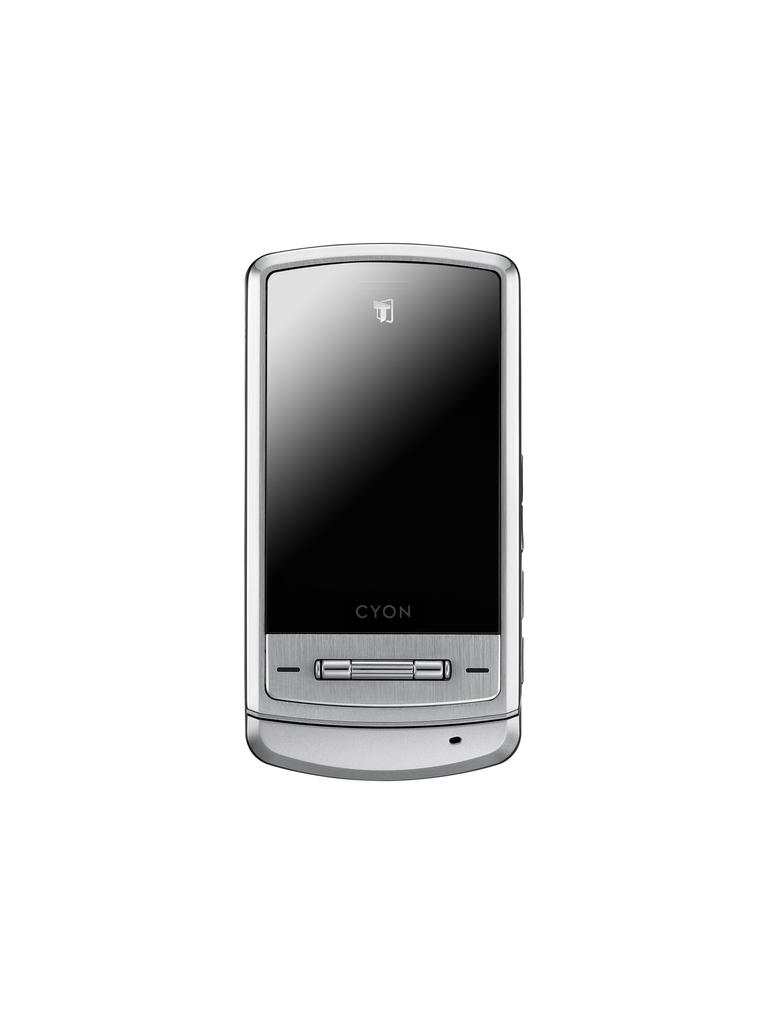What brand phone is this?
Your answer should be very brief. Cyon. 